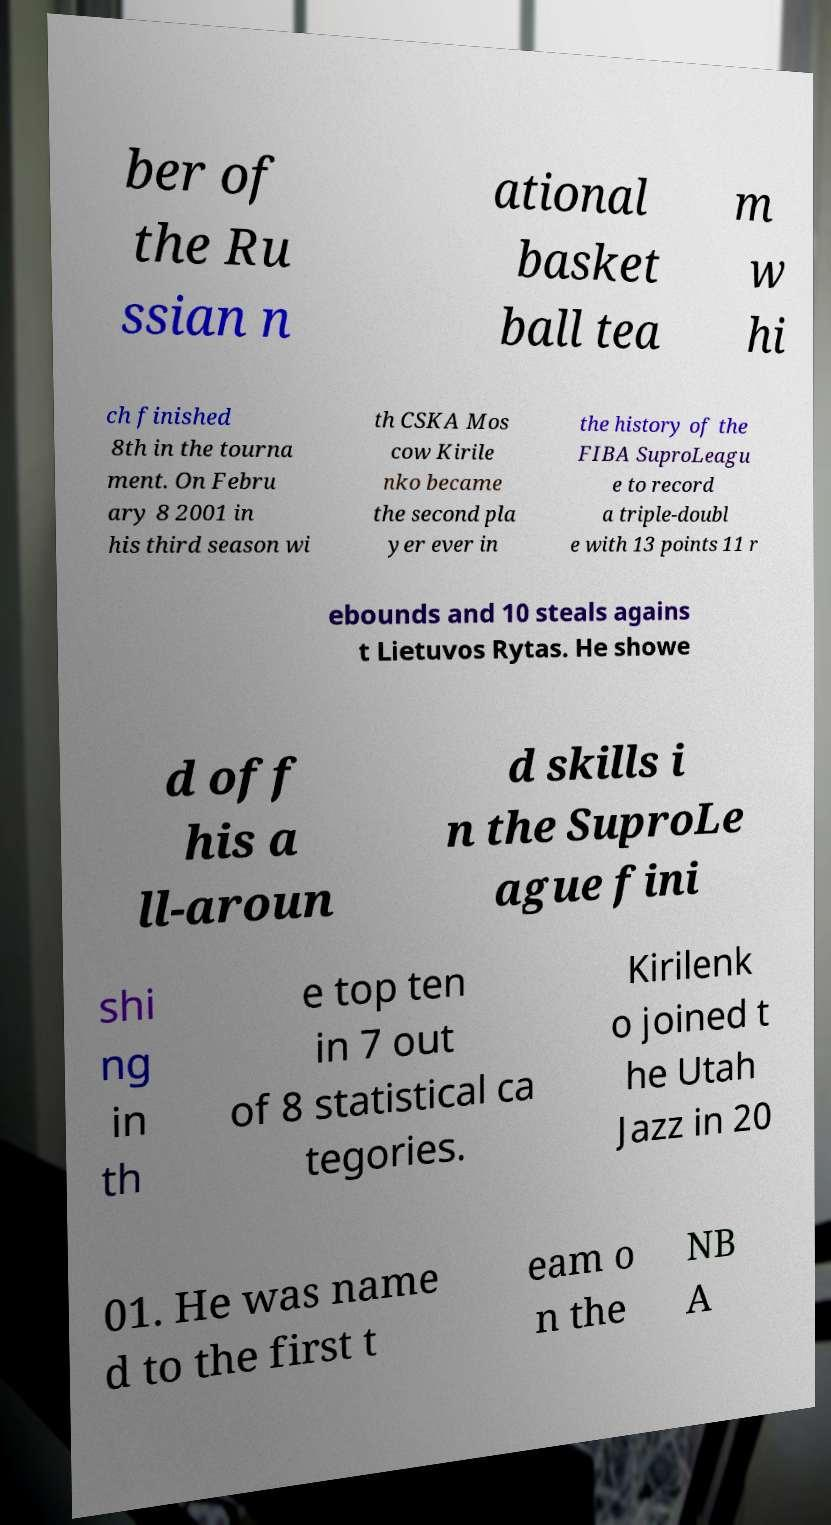What messages or text are displayed in this image? I need them in a readable, typed format. ber of the Ru ssian n ational basket ball tea m w hi ch finished 8th in the tourna ment. On Febru ary 8 2001 in his third season wi th CSKA Mos cow Kirile nko became the second pla yer ever in the history of the FIBA SuproLeagu e to record a triple-doubl e with 13 points 11 r ebounds and 10 steals agains t Lietuvos Rytas. He showe d off his a ll-aroun d skills i n the SuproLe ague fini shi ng in th e top ten in 7 out of 8 statistical ca tegories. Kirilenk o joined t he Utah Jazz in 20 01. He was name d to the first t eam o n the NB A 